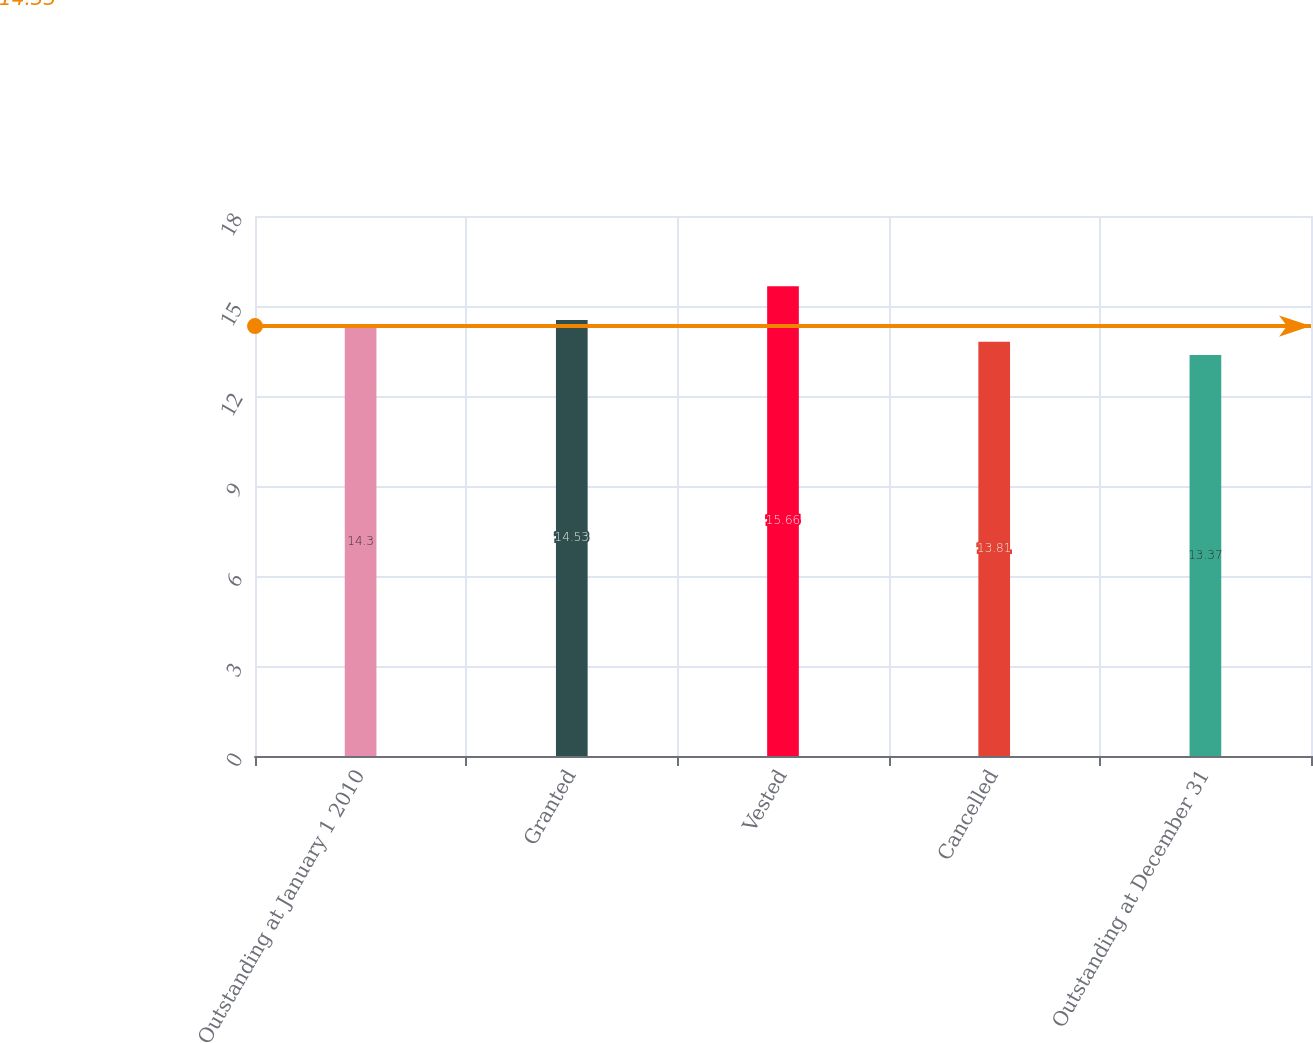Convert chart. <chart><loc_0><loc_0><loc_500><loc_500><bar_chart><fcel>Outstanding at January 1 2010<fcel>Granted<fcel>Vested<fcel>Cancelled<fcel>Outstanding at December 31<nl><fcel>14.3<fcel>14.53<fcel>15.66<fcel>13.81<fcel>13.37<nl></chart> 